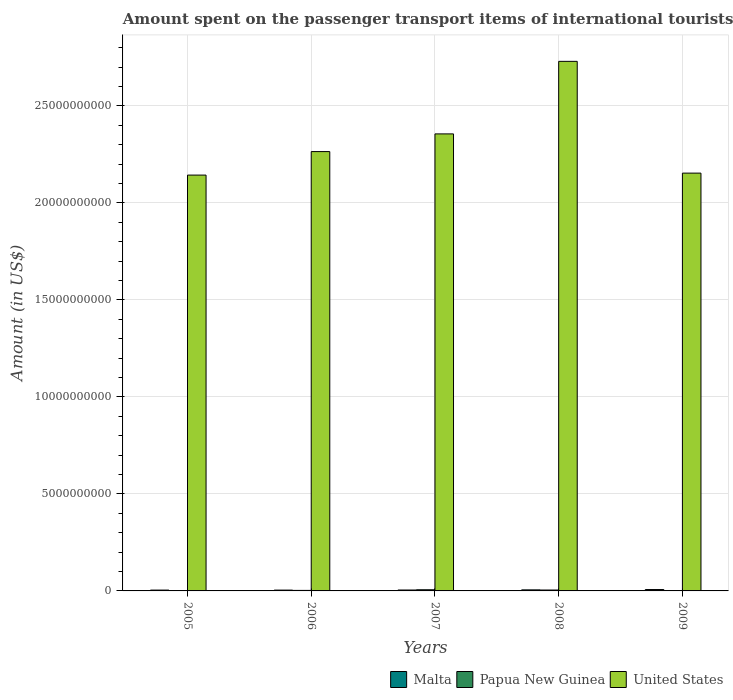How many groups of bars are there?
Your response must be concise. 5. Are the number of bars per tick equal to the number of legend labels?
Give a very brief answer. Yes. How many bars are there on the 2nd tick from the right?
Your response must be concise. 3. What is the label of the 3rd group of bars from the left?
Offer a terse response. 2007. What is the amount spent on the passenger transport items of international tourists in United States in 2009?
Your response must be concise. 2.15e+1. Across all years, what is the maximum amount spent on the passenger transport items of international tourists in Malta?
Provide a short and direct response. 7.10e+07. Across all years, what is the minimum amount spent on the passenger transport items of international tourists in Malta?
Keep it short and to the point. 4.20e+07. What is the total amount spent on the passenger transport items of international tourists in Papua New Guinea in the graph?
Provide a succinct answer. 1.53e+08. What is the difference between the amount spent on the passenger transport items of international tourists in Papua New Guinea in 2005 and that in 2008?
Your response must be concise. -4.54e+07. What is the difference between the amount spent on the passenger transport items of international tourists in Malta in 2008 and the amount spent on the passenger transport items of international tourists in Papua New Guinea in 2005?
Make the answer very short. 5.34e+07. What is the average amount spent on the passenger transport items of international tourists in Papua New Guinea per year?
Offer a terse response. 3.05e+07. In the year 2008, what is the difference between the amount spent on the passenger transport items of international tourists in Malta and amount spent on the passenger transport items of international tourists in Papua New Guinea?
Give a very brief answer. 8.00e+06. In how many years, is the amount spent on the passenger transport items of international tourists in Malta greater than 15000000000 US$?
Provide a short and direct response. 0. What is the ratio of the amount spent on the passenger transport items of international tourists in Papua New Guinea in 2006 to that in 2009?
Give a very brief answer. 1.42. Is the amount spent on the passenger transport items of international tourists in Papua New Guinea in 2008 less than that in 2009?
Your answer should be very brief. No. What is the difference between the highest and the second highest amount spent on the passenger transport items of international tourists in Malta?
Your response must be concise. 1.70e+07. What is the difference between the highest and the lowest amount spent on the passenger transport items of international tourists in Papua New Guinea?
Give a very brief answer. 5.94e+07. In how many years, is the amount spent on the passenger transport items of international tourists in United States greater than the average amount spent on the passenger transport items of international tourists in United States taken over all years?
Your response must be concise. 2. Is the sum of the amount spent on the passenger transport items of international tourists in United States in 2006 and 2009 greater than the maximum amount spent on the passenger transport items of international tourists in Papua New Guinea across all years?
Keep it short and to the point. Yes. What does the 1st bar from the left in 2007 represents?
Provide a short and direct response. Malta. What does the 2nd bar from the right in 2006 represents?
Ensure brevity in your answer.  Papua New Guinea. Is it the case that in every year, the sum of the amount spent on the passenger transport items of international tourists in United States and amount spent on the passenger transport items of international tourists in Papua New Guinea is greater than the amount spent on the passenger transport items of international tourists in Malta?
Your answer should be compact. Yes. How many bars are there?
Make the answer very short. 15. Does the graph contain grids?
Ensure brevity in your answer.  Yes. How are the legend labels stacked?
Your answer should be compact. Horizontal. What is the title of the graph?
Make the answer very short. Amount spent on the passenger transport items of international tourists. Does "Oman" appear as one of the legend labels in the graph?
Ensure brevity in your answer.  No. What is the label or title of the Y-axis?
Give a very brief answer. Amount (in US$). What is the Amount (in US$) in Malta in 2005?
Provide a short and direct response. 4.30e+07. What is the Amount (in US$) of Papua New Guinea in 2005?
Ensure brevity in your answer.  6.00e+05. What is the Amount (in US$) in United States in 2005?
Provide a succinct answer. 2.14e+1. What is the Amount (in US$) of Malta in 2006?
Keep it short and to the point. 4.20e+07. What is the Amount (in US$) of Papua New Guinea in 2006?
Provide a short and direct response. 2.70e+07. What is the Amount (in US$) in United States in 2006?
Your answer should be compact. 2.26e+1. What is the Amount (in US$) of Malta in 2007?
Keep it short and to the point. 4.70e+07. What is the Amount (in US$) in Papua New Guinea in 2007?
Make the answer very short. 6.00e+07. What is the Amount (in US$) in United States in 2007?
Make the answer very short. 2.36e+1. What is the Amount (in US$) in Malta in 2008?
Offer a very short reply. 5.40e+07. What is the Amount (in US$) of Papua New Guinea in 2008?
Offer a very short reply. 4.60e+07. What is the Amount (in US$) of United States in 2008?
Offer a terse response. 2.73e+1. What is the Amount (in US$) in Malta in 2009?
Offer a very short reply. 7.10e+07. What is the Amount (in US$) of Papua New Guinea in 2009?
Make the answer very short. 1.90e+07. What is the Amount (in US$) in United States in 2009?
Your answer should be compact. 2.15e+1. Across all years, what is the maximum Amount (in US$) in Malta?
Your response must be concise. 7.10e+07. Across all years, what is the maximum Amount (in US$) of Papua New Guinea?
Your answer should be compact. 6.00e+07. Across all years, what is the maximum Amount (in US$) in United States?
Keep it short and to the point. 2.73e+1. Across all years, what is the minimum Amount (in US$) of Malta?
Your answer should be very brief. 4.20e+07. Across all years, what is the minimum Amount (in US$) in Papua New Guinea?
Your answer should be compact. 6.00e+05. Across all years, what is the minimum Amount (in US$) of United States?
Your response must be concise. 2.14e+1. What is the total Amount (in US$) of Malta in the graph?
Your answer should be very brief. 2.57e+08. What is the total Amount (in US$) in Papua New Guinea in the graph?
Make the answer very short. 1.53e+08. What is the total Amount (in US$) in United States in the graph?
Give a very brief answer. 1.16e+11. What is the difference between the Amount (in US$) of Papua New Guinea in 2005 and that in 2006?
Your answer should be compact. -2.64e+07. What is the difference between the Amount (in US$) of United States in 2005 and that in 2006?
Offer a very short reply. -1.21e+09. What is the difference between the Amount (in US$) in Papua New Guinea in 2005 and that in 2007?
Your response must be concise. -5.94e+07. What is the difference between the Amount (in US$) of United States in 2005 and that in 2007?
Make the answer very short. -2.12e+09. What is the difference between the Amount (in US$) of Malta in 2005 and that in 2008?
Offer a terse response. -1.10e+07. What is the difference between the Amount (in US$) in Papua New Guinea in 2005 and that in 2008?
Provide a succinct answer. -4.54e+07. What is the difference between the Amount (in US$) of United States in 2005 and that in 2008?
Your response must be concise. -5.86e+09. What is the difference between the Amount (in US$) in Malta in 2005 and that in 2009?
Your answer should be compact. -2.80e+07. What is the difference between the Amount (in US$) in Papua New Guinea in 2005 and that in 2009?
Your answer should be compact. -1.84e+07. What is the difference between the Amount (in US$) in United States in 2005 and that in 2009?
Give a very brief answer. -1.01e+08. What is the difference between the Amount (in US$) in Malta in 2006 and that in 2007?
Your answer should be compact. -5.00e+06. What is the difference between the Amount (in US$) of Papua New Guinea in 2006 and that in 2007?
Keep it short and to the point. -3.30e+07. What is the difference between the Amount (in US$) in United States in 2006 and that in 2007?
Your answer should be very brief. -9.11e+08. What is the difference between the Amount (in US$) of Malta in 2006 and that in 2008?
Offer a terse response. -1.20e+07. What is the difference between the Amount (in US$) in Papua New Guinea in 2006 and that in 2008?
Your response must be concise. -1.90e+07. What is the difference between the Amount (in US$) of United States in 2006 and that in 2008?
Offer a terse response. -4.65e+09. What is the difference between the Amount (in US$) in Malta in 2006 and that in 2009?
Make the answer very short. -2.90e+07. What is the difference between the Amount (in US$) in United States in 2006 and that in 2009?
Offer a terse response. 1.11e+09. What is the difference between the Amount (in US$) of Malta in 2007 and that in 2008?
Your answer should be compact. -7.00e+06. What is the difference between the Amount (in US$) in Papua New Guinea in 2007 and that in 2008?
Your answer should be compact. 1.40e+07. What is the difference between the Amount (in US$) in United States in 2007 and that in 2008?
Provide a short and direct response. -3.74e+09. What is the difference between the Amount (in US$) in Malta in 2007 and that in 2009?
Make the answer very short. -2.40e+07. What is the difference between the Amount (in US$) of Papua New Guinea in 2007 and that in 2009?
Give a very brief answer. 4.10e+07. What is the difference between the Amount (in US$) of United States in 2007 and that in 2009?
Give a very brief answer. 2.02e+09. What is the difference between the Amount (in US$) in Malta in 2008 and that in 2009?
Your answer should be very brief. -1.70e+07. What is the difference between the Amount (in US$) of Papua New Guinea in 2008 and that in 2009?
Offer a very short reply. 2.70e+07. What is the difference between the Amount (in US$) of United States in 2008 and that in 2009?
Offer a very short reply. 5.76e+09. What is the difference between the Amount (in US$) in Malta in 2005 and the Amount (in US$) in Papua New Guinea in 2006?
Offer a very short reply. 1.60e+07. What is the difference between the Amount (in US$) of Malta in 2005 and the Amount (in US$) of United States in 2006?
Provide a succinct answer. -2.26e+1. What is the difference between the Amount (in US$) of Papua New Guinea in 2005 and the Amount (in US$) of United States in 2006?
Provide a short and direct response. -2.26e+1. What is the difference between the Amount (in US$) in Malta in 2005 and the Amount (in US$) in Papua New Guinea in 2007?
Provide a short and direct response. -1.70e+07. What is the difference between the Amount (in US$) of Malta in 2005 and the Amount (in US$) of United States in 2007?
Ensure brevity in your answer.  -2.35e+1. What is the difference between the Amount (in US$) in Papua New Guinea in 2005 and the Amount (in US$) in United States in 2007?
Keep it short and to the point. -2.36e+1. What is the difference between the Amount (in US$) in Malta in 2005 and the Amount (in US$) in Papua New Guinea in 2008?
Your response must be concise. -3.00e+06. What is the difference between the Amount (in US$) of Malta in 2005 and the Amount (in US$) of United States in 2008?
Your answer should be very brief. -2.72e+1. What is the difference between the Amount (in US$) of Papua New Guinea in 2005 and the Amount (in US$) of United States in 2008?
Your answer should be compact. -2.73e+1. What is the difference between the Amount (in US$) of Malta in 2005 and the Amount (in US$) of Papua New Guinea in 2009?
Give a very brief answer. 2.40e+07. What is the difference between the Amount (in US$) of Malta in 2005 and the Amount (in US$) of United States in 2009?
Make the answer very short. -2.15e+1. What is the difference between the Amount (in US$) in Papua New Guinea in 2005 and the Amount (in US$) in United States in 2009?
Your response must be concise. -2.15e+1. What is the difference between the Amount (in US$) in Malta in 2006 and the Amount (in US$) in Papua New Guinea in 2007?
Offer a terse response. -1.80e+07. What is the difference between the Amount (in US$) in Malta in 2006 and the Amount (in US$) in United States in 2007?
Offer a terse response. -2.35e+1. What is the difference between the Amount (in US$) in Papua New Guinea in 2006 and the Amount (in US$) in United States in 2007?
Offer a very short reply. -2.35e+1. What is the difference between the Amount (in US$) in Malta in 2006 and the Amount (in US$) in United States in 2008?
Your answer should be very brief. -2.72e+1. What is the difference between the Amount (in US$) of Papua New Guinea in 2006 and the Amount (in US$) of United States in 2008?
Make the answer very short. -2.73e+1. What is the difference between the Amount (in US$) in Malta in 2006 and the Amount (in US$) in Papua New Guinea in 2009?
Keep it short and to the point. 2.30e+07. What is the difference between the Amount (in US$) of Malta in 2006 and the Amount (in US$) of United States in 2009?
Make the answer very short. -2.15e+1. What is the difference between the Amount (in US$) in Papua New Guinea in 2006 and the Amount (in US$) in United States in 2009?
Give a very brief answer. -2.15e+1. What is the difference between the Amount (in US$) of Malta in 2007 and the Amount (in US$) of United States in 2008?
Ensure brevity in your answer.  -2.72e+1. What is the difference between the Amount (in US$) of Papua New Guinea in 2007 and the Amount (in US$) of United States in 2008?
Offer a terse response. -2.72e+1. What is the difference between the Amount (in US$) of Malta in 2007 and the Amount (in US$) of Papua New Guinea in 2009?
Provide a succinct answer. 2.80e+07. What is the difference between the Amount (in US$) in Malta in 2007 and the Amount (in US$) in United States in 2009?
Offer a very short reply. -2.15e+1. What is the difference between the Amount (in US$) of Papua New Guinea in 2007 and the Amount (in US$) of United States in 2009?
Your answer should be very brief. -2.15e+1. What is the difference between the Amount (in US$) in Malta in 2008 and the Amount (in US$) in Papua New Guinea in 2009?
Offer a very short reply. 3.50e+07. What is the difference between the Amount (in US$) of Malta in 2008 and the Amount (in US$) of United States in 2009?
Your answer should be compact. -2.15e+1. What is the difference between the Amount (in US$) of Papua New Guinea in 2008 and the Amount (in US$) of United States in 2009?
Ensure brevity in your answer.  -2.15e+1. What is the average Amount (in US$) of Malta per year?
Offer a very short reply. 5.14e+07. What is the average Amount (in US$) of Papua New Guinea per year?
Provide a succinct answer. 3.05e+07. What is the average Amount (in US$) of United States per year?
Your answer should be very brief. 2.33e+1. In the year 2005, what is the difference between the Amount (in US$) of Malta and Amount (in US$) of Papua New Guinea?
Your answer should be compact. 4.24e+07. In the year 2005, what is the difference between the Amount (in US$) of Malta and Amount (in US$) of United States?
Offer a terse response. -2.14e+1. In the year 2005, what is the difference between the Amount (in US$) in Papua New Guinea and Amount (in US$) in United States?
Your answer should be very brief. -2.14e+1. In the year 2006, what is the difference between the Amount (in US$) of Malta and Amount (in US$) of Papua New Guinea?
Provide a short and direct response. 1.50e+07. In the year 2006, what is the difference between the Amount (in US$) of Malta and Amount (in US$) of United States?
Offer a very short reply. -2.26e+1. In the year 2006, what is the difference between the Amount (in US$) in Papua New Guinea and Amount (in US$) in United States?
Make the answer very short. -2.26e+1. In the year 2007, what is the difference between the Amount (in US$) in Malta and Amount (in US$) in Papua New Guinea?
Provide a short and direct response. -1.30e+07. In the year 2007, what is the difference between the Amount (in US$) in Malta and Amount (in US$) in United States?
Your response must be concise. -2.35e+1. In the year 2007, what is the difference between the Amount (in US$) of Papua New Guinea and Amount (in US$) of United States?
Offer a terse response. -2.35e+1. In the year 2008, what is the difference between the Amount (in US$) in Malta and Amount (in US$) in Papua New Guinea?
Give a very brief answer. 8.00e+06. In the year 2008, what is the difference between the Amount (in US$) of Malta and Amount (in US$) of United States?
Keep it short and to the point. -2.72e+1. In the year 2008, what is the difference between the Amount (in US$) of Papua New Guinea and Amount (in US$) of United States?
Offer a terse response. -2.72e+1. In the year 2009, what is the difference between the Amount (in US$) in Malta and Amount (in US$) in Papua New Guinea?
Make the answer very short. 5.20e+07. In the year 2009, what is the difference between the Amount (in US$) in Malta and Amount (in US$) in United States?
Provide a short and direct response. -2.15e+1. In the year 2009, what is the difference between the Amount (in US$) in Papua New Guinea and Amount (in US$) in United States?
Provide a succinct answer. -2.15e+1. What is the ratio of the Amount (in US$) in Malta in 2005 to that in 2006?
Make the answer very short. 1.02. What is the ratio of the Amount (in US$) of Papua New Guinea in 2005 to that in 2006?
Give a very brief answer. 0.02. What is the ratio of the Amount (in US$) of United States in 2005 to that in 2006?
Your answer should be very brief. 0.95. What is the ratio of the Amount (in US$) in Malta in 2005 to that in 2007?
Your answer should be compact. 0.91. What is the ratio of the Amount (in US$) in Papua New Guinea in 2005 to that in 2007?
Ensure brevity in your answer.  0.01. What is the ratio of the Amount (in US$) in United States in 2005 to that in 2007?
Offer a very short reply. 0.91. What is the ratio of the Amount (in US$) of Malta in 2005 to that in 2008?
Provide a short and direct response. 0.8. What is the ratio of the Amount (in US$) in Papua New Guinea in 2005 to that in 2008?
Offer a terse response. 0.01. What is the ratio of the Amount (in US$) of United States in 2005 to that in 2008?
Your response must be concise. 0.79. What is the ratio of the Amount (in US$) in Malta in 2005 to that in 2009?
Provide a short and direct response. 0.61. What is the ratio of the Amount (in US$) in Papua New Guinea in 2005 to that in 2009?
Your answer should be compact. 0.03. What is the ratio of the Amount (in US$) of Malta in 2006 to that in 2007?
Provide a succinct answer. 0.89. What is the ratio of the Amount (in US$) of Papua New Guinea in 2006 to that in 2007?
Your answer should be compact. 0.45. What is the ratio of the Amount (in US$) in United States in 2006 to that in 2007?
Offer a very short reply. 0.96. What is the ratio of the Amount (in US$) in Malta in 2006 to that in 2008?
Make the answer very short. 0.78. What is the ratio of the Amount (in US$) of Papua New Guinea in 2006 to that in 2008?
Your answer should be compact. 0.59. What is the ratio of the Amount (in US$) of United States in 2006 to that in 2008?
Give a very brief answer. 0.83. What is the ratio of the Amount (in US$) of Malta in 2006 to that in 2009?
Offer a terse response. 0.59. What is the ratio of the Amount (in US$) of Papua New Guinea in 2006 to that in 2009?
Your response must be concise. 1.42. What is the ratio of the Amount (in US$) of United States in 2006 to that in 2009?
Keep it short and to the point. 1.05. What is the ratio of the Amount (in US$) in Malta in 2007 to that in 2008?
Provide a short and direct response. 0.87. What is the ratio of the Amount (in US$) in Papua New Guinea in 2007 to that in 2008?
Your answer should be very brief. 1.3. What is the ratio of the Amount (in US$) in United States in 2007 to that in 2008?
Keep it short and to the point. 0.86. What is the ratio of the Amount (in US$) in Malta in 2007 to that in 2009?
Provide a succinct answer. 0.66. What is the ratio of the Amount (in US$) of Papua New Guinea in 2007 to that in 2009?
Offer a very short reply. 3.16. What is the ratio of the Amount (in US$) in United States in 2007 to that in 2009?
Your answer should be very brief. 1.09. What is the ratio of the Amount (in US$) in Malta in 2008 to that in 2009?
Make the answer very short. 0.76. What is the ratio of the Amount (in US$) of Papua New Guinea in 2008 to that in 2009?
Keep it short and to the point. 2.42. What is the ratio of the Amount (in US$) of United States in 2008 to that in 2009?
Keep it short and to the point. 1.27. What is the difference between the highest and the second highest Amount (in US$) in Malta?
Offer a terse response. 1.70e+07. What is the difference between the highest and the second highest Amount (in US$) of Papua New Guinea?
Offer a terse response. 1.40e+07. What is the difference between the highest and the second highest Amount (in US$) in United States?
Offer a very short reply. 3.74e+09. What is the difference between the highest and the lowest Amount (in US$) in Malta?
Keep it short and to the point. 2.90e+07. What is the difference between the highest and the lowest Amount (in US$) of Papua New Guinea?
Your answer should be compact. 5.94e+07. What is the difference between the highest and the lowest Amount (in US$) of United States?
Give a very brief answer. 5.86e+09. 